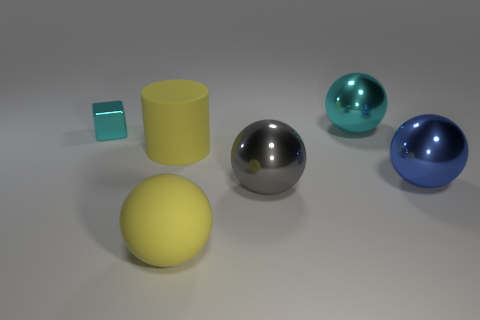There is a blue object that is the same size as the rubber sphere; what is it made of?
Provide a short and direct response. Metal. Is there another ball made of the same material as the yellow ball?
Your answer should be very brief. No. Does the big gray thing have the same shape as the yellow object on the left side of the large rubber ball?
Keep it short and to the point. No. How many metallic balls are left of the blue metal ball and on the right side of the large gray object?
Provide a short and direct response. 1. Do the cyan ball and the cyan thing left of the yellow rubber sphere have the same material?
Offer a very short reply. Yes. Is the number of large metal spheres that are to the right of the cyan cube the same as the number of red cylinders?
Provide a short and direct response. No. The ball that is behind the small cyan thing is what color?
Provide a short and direct response. Cyan. How many other things are there of the same color as the metallic block?
Your answer should be compact. 1. Are there any other things that are the same size as the blue metallic object?
Provide a succinct answer. Yes. Is the size of the yellow rubber object that is in front of the yellow cylinder the same as the big yellow cylinder?
Keep it short and to the point. Yes. 